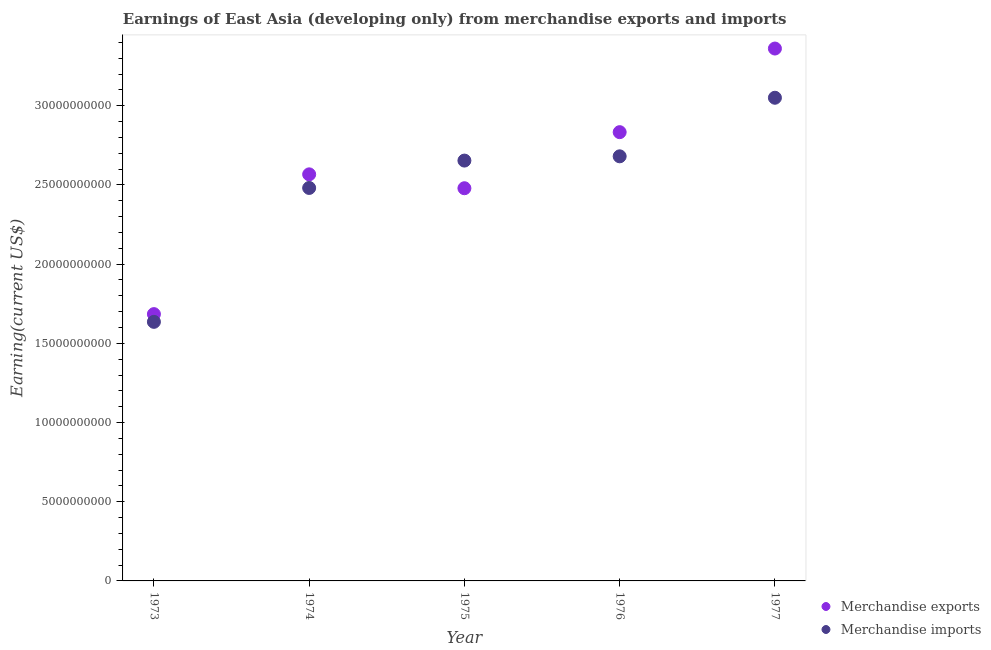How many different coloured dotlines are there?
Your answer should be compact. 2. What is the earnings from merchandise imports in 1976?
Offer a very short reply. 2.68e+1. Across all years, what is the maximum earnings from merchandise imports?
Your answer should be very brief. 3.05e+1. Across all years, what is the minimum earnings from merchandise exports?
Provide a short and direct response. 1.68e+1. In which year was the earnings from merchandise exports minimum?
Ensure brevity in your answer.  1973. What is the total earnings from merchandise exports in the graph?
Your answer should be compact. 1.29e+11. What is the difference between the earnings from merchandise exports in 1973 and that in 1977?
Make the answer very short. -1.68e+1. What is the difference between the earnings from merchandise imports in 1974 and the earnings from merchandise exports in 1973?
Your answer should be very brief. 7.97e+09. What is the average earnings from merchandise imports per year?
Your answer should be very brief. 2.50e+1. In the year 1977, what is the difference between the earnings from merchandise exports and earnings from merchandise imports?
Give a very brief answer. 3.11e+09. In how many years, is the earnings from merchandise imports greater than 18000000000 US$?
Your answer should be compact. 4. What is the ratio of the earnings from merchandise imports in 1975 to that in 1976?
Your answer should be very brief. 0.99. Is the earnings from merchandise imports in 1974 less than that in 1976?
Provide a succinct answer. Yes. What is the difference between the highest and the second highest earnings from merchandise exports?
Provide a short and direct response. 5.28e+09. What is the difference between the highest and the lowest earnings from merchandise exports?
Your answer should be very brief. 1.68e+1. In how many years, is the earnings from merchandise imports greater than the average earnings from merchandise imports taken over all years?
Make the answer very short. 3. Does the earnings from merchandise exports monotonically increase over the years?
Ensure brevity in your answer.  No. Is the earnings from merchandise imports strictly greater than the earnings from merchandise exports over the years?
Ensure brevity in your answer.  No. Is the earnings from merchandise imports strictly less than the earnings from merchandise exports over the years?
Offer a very short reply. No. Are the values on the major ticks of Y-axis written in scientific E-notation?
Provide a succinct answer. No. Does the graph contain grids?
Your answer should be very brief. No. How are the legend labels stacked?
Provide a succinct answer. Vertical. What is the title of the graph?
Offer a terse response. Earnings of East Asia (developing only) from merchandise exports and imports. What is the label or title of the Y-axis?
Your answer should be compact. Earning(current US$). What is the Earning(current US$) in Merchandise exports in 1973?
Offer a terse response. 1.68e+1. What is the Earning(current US$) in Merchandise imports in 1973?
Your answer should be compact. 1.64e+1. What is the Earning(current US$) of Merchandise exports in 1974?
Your response must be concise. 2.57e+1. What is the Earning(current US$) of Merchandise imports in 1974?
Offer a very short reply. 2.48e+1. What is the Earning(current US$) in Merchandise exports in 1975?
Ensure brevity in your answer.  2.48e+1. What is the Earning(current US$) in Merchandise imports in 1975?
Offer a very short reply. 2.65e+1. What is the Earning(current US$) of Merchandise exports in 1976?
Your response must be concise. 2.83e+1. What is the Earning(current US$) of Merchandise imports in 1976?
Your answer should be compact. 2.68e+1. What is the Earning(current US$) in Merchandise exports in 1977?
Keep it short and to the point. 3.36e+1. What is the Earning(current US$) in Merchandise imports in 1977?
Your answer should be compact. 3.05e+1. Across all years, what is the maximum Earning(current US$) in Merchandise exports?
Offer a terse response. 3.36e+1. Across all years, what is the maximum Earning(current US$) in Merchandise imports?
Your answer should be compact. 3.05e+1. Across all years, what is the minimum Earning(current US$) of Merchandise exports?
Provide a succinct answer. 1.68e+1. Across all years, what is the minimum Earning(current US$) in Merchandise imports?
Provide a short and direct response. 1.64e+1. What is the total Earning(current US$) of Merchandise exports in the graph?
Your response must be concise. 1.29e+11. What is the total Earning(current US$) in Merchandise imports in the graph?
Provide a short and direct response. 1.25e+11. What is the difference between the Earning(current US$) in Merchandise exports in 1973 and that in 1974?
Keep it short and to the point. -8.82e+09. What is the difference between the Earning(current US$) in Merchandise imports in 1973 and that in 1974?
Offer a terse response. -8.45e+09. What is the difference between the Earning(current US$) in Merchandise exports in 1973 and that in 1975?
Offer a very short reply. -7.95e+09. What is the difference between the Earning(current US$) of Merchandise imports in 1973 and that in 1975?
Ensure brevity in your answer.  -1.02e+1. What is the difference between the Earning(current US$) of Merchandise exports in 1973 and that in 1976?
Your answer should be compact. -1.15e+1. What is the difference between the Earning(current US$) of Merchandise imports in 1973 and that in 1976?
Ensure brevity in your answer.  -1.05e+1. What is the difference between the Earning(current US$) of Merchandise exports in 1973 and that in 1977?
Keep it short and to the point. -1.68e+1. What is the difference between the Earning(current US$) in Merchandise imports in 1973 and that in 1977?
Your answer should be very brief. -1.41e+1. What is the difference between the Earning(current US$) of Merchandise exports in 1974 and that in 1975?
Your answer should be very brief. 8.77e+08. What is the difference between the Earning(current US$) of Merchandise imports in 1974 and that in 1975?
Ensure brevity in your answer.  -1.73e+09. What is the difference between the Earning(current US$) in Merchandise exports in 1974 and that in 1976?
Offer a very short reply. -2.66e+09. What is the difference between the Earning(current US$) of Merchandise imports in 1974 and that in 1976?
Offer a terse response. -2.00e+09. What is the difference between the Earning(current US$) of Merchandise exports in 1974 and that in 1977?
Offer a terse response. -7.94e+09. What is the difference between the Earning(current US$) in Merchandise imports in 1974 and that in 1977?
Ensure brevity in your answer.  -5.69e+09. What is the difference between the Earning(current US$) in Merchandise exports in 1975 and that in 1976?
Give a very brief answer. -3.54e+09. What is the difference between the Earning(current US$) of Merchandise imports in 1975 and that in 1976?
Ensure brevity in your answer.  -2.69e+08. What is the difference between the Earning(current US$) of Merchandise exports in 1975 and that in 1977?
Give a very brief answer. -8.82e+09. What is the difference between the Earning(current US$) of Merchandise imports in 1975 and that in 1977?
Offer a terse response. -3.97e+09. What is the difference between the Earning(current US$) of Merchandise exports in 1976 and that in 1977?
Offer a very short reply. -5.28e+09. What is the difference between the Earning(current US$) in Merchandise imports in 1976 and that in 1977?
Your answer should be compact. -3.70e+09. What is the difference between the Earning(current US$) in Merchandise exports in 1973 and the Earning(current US$) in Merchandise imports in 1974?
Your answer should be very brief. -7.97e+09. What is the difference between the Earning(current US$) in Merchandise exports in 1973 and the Earning(current US$) in Merchandise imports in 1975?
Your response must be concise. -9.69e+09. What is the difference between the Earning(current US$) in Merchandise exports in 1973 and the Earning(current US$) in Merchandise imports in 1976?
Provide a short and direct response. -9.96e+09. What is the difference between the Earning(current US$) in Merchandise exports in 1973 and the Earning(current US$) in Merchandise imports in 1977?
Give a very brief answer. -1.37e+1. What is the difference between the Earning(current US$) in Merchandise exports in 1974 and the Earning(current US$) in Merchandise imports in 1975?
Offer a terse response. -8.69e+08. What is the difference between the Earning(current US$) in Merchandise exports in 1974 and the Earning(current US$) in Merchandise imports in 1976?
Your response must be concise. -1.14e+09. What is the difference between the Earning(current US$) of Merchandise exports in 1974 and the Earning(current US$) of Merchandise imports in 1977?
Your answer should be compact. -4.84e+09. What is the difference between the Earning(current US$) in Merchandise exports in 1975 and the Earning(current US$) in Merchandise imports in 1976?
Give a very brief answer. -2.01e+09. What is the difference between the Earning(current US$) in Merchandise exports in 1975 and the Earning(current US$) in Merchandise imports in 1977?
Offer a terse response. -5.71e+09. What is the difference between the Earning(current US$) in Merchandise exports in 1976 and the Earning(current US$) in Merchandise imports in 1977?
Make the answer very short. -2.17e+09. What is the average Earning(current US$) of Merchandise exports per year?
Keep it short and to the point. 2.58e+1. What is the average Earning(current US$) of Merchandise imports per year?
Keep it short and to the point. 2.50e+1. In the year 1973, what is the difference between the Earning(current US$) in Merchandise exports and Earning(current US$) in Merchandise imports?
Offer a terse response. 4.88e+08. In the year 1974, what is the difference between the Earning(current US$) in Merchandise exports and Earning(current US$) in Merchandise imports?
Offer a terse response. 8.59e+08. In the year 1975, what is the difference between the Earning(current US$) in Merchandise exports and Earning(current US$) in Merchandise imports?
Ensure brevity in your answer.  -1.75e+09. In the year 1976, what is the difference between the Earning(current US$) of Merchandise exports and Earning(current US$) of Merchandise imports?
Offer a terse response. 1.53e+09. In the year 1977, what is the difference between the Earning(current US$) of Merchandise exports and Earning(current US$) of Merchandise imports?
Your answer should be very brief. 3.11e+09. What is the ratio of the Earning(current US$) in Merchandise exports in 1973 to that in 1974?
Ensure brevity in your answer.  0.66. What is the ratio of the Earning(current US$) of Merchandise imports in 1973 to that in 1974?
Your answer should be compact. 0.66. What is the ratio of the Earning(current US$) of Merchandise exports in 1973 to that in 1975?
Provide a succinct answer. 0.68. What is the ratio of the Earning(current US$) of Merchandise imports in 1973 to that in 1975?
Provide a succinct answer. 0.62. What is the ratio of the Earning(current US$) of Merchandise exports in 1973 to that in 1976?
Give a very brief answer. 0.59. What is the ratio of the Earning(current US$) of Merchandise imports in 1973 to that in 1976?
Make the answer very short. 0.61. What is the ratio of the Earning(current US$) in Merchandise exports in 1973 to that in 1977?
Provide a succinct answer. 0.5. What is the ratio of the Earning(current US$) of Merchandise imports in 1973 to that in 1977?
Ensure brevity in your answer.  0.54. What is the ratio of the Earning(current US$) of Merchandise exports in 1974 to that in 1975?
Give a very brief answer. 1.04. What is the ratio of the Earning(current US$) in Merchandise imports in 1974 to that in 1975?
Make the answer very short. 0.93. What is the ratio of the Earning(current US$) in Merchandise exports in 1974 to that in 1976?
Provide a short and direct response. 0.91. What is the ratio of the Earning(current US$) in Merchandise imports in 1974 to that in 1976?
Provide a succinct answer. 0.93. What is the ratio of the Earning(current US$) of Merchandise exports in 1974 to that in 1977?
Your answer should be very brief. 0.76. What is the ratio of the Earning(current US$) in Merchandise imports in 1974 to that in 1977?
Provide a short and direct response. 0.81. What is the ratio of the Earning(current US$) in Merchandise exports in 1975 to that in 1976?
Your answer should be compact. 0.88. What is the ratio of the Earning(current US$) in Merchandise imports in 1975 to that in 1976?
Provide a short and direct response. 0.99. What is the ratio of the Earning(current US$) in Merchandise exports in 1975 to that in 1977?
Your answer should be compact. 0.74. What is the ratio of the Earning(current US$) of Merchandise imports in 1975 to that in 1977?
Provide a succinct answer. 0.87. What is the ratio of the Earning(current US$) in Merchandise exports in 1976 to that in 1977?
Make the answer very short. 0.84. What is the ratio of the Earning(current US$) in Merchandise imports in 1976 to that in 1977?
Provide a succinct answer. 0.88. What is the difference between the highest and the second highest Earning(current US$) of Merchandise exports?
Your answer should be compact. 5.28e+09. What is the difference between the highest and the second highest Earning(current US$) of Merchandise imports?
Offer a terse response. 3.70e+09. What is the difference between the highest and the lowest Earning(current US$) in Merchandise exports?
Your answer should be compact. 1.68e+1. What is the difference between the highest and the lowest Earning(current US$) of Merchandise imports?
Provide a short and direct response. 1.41e+1. 